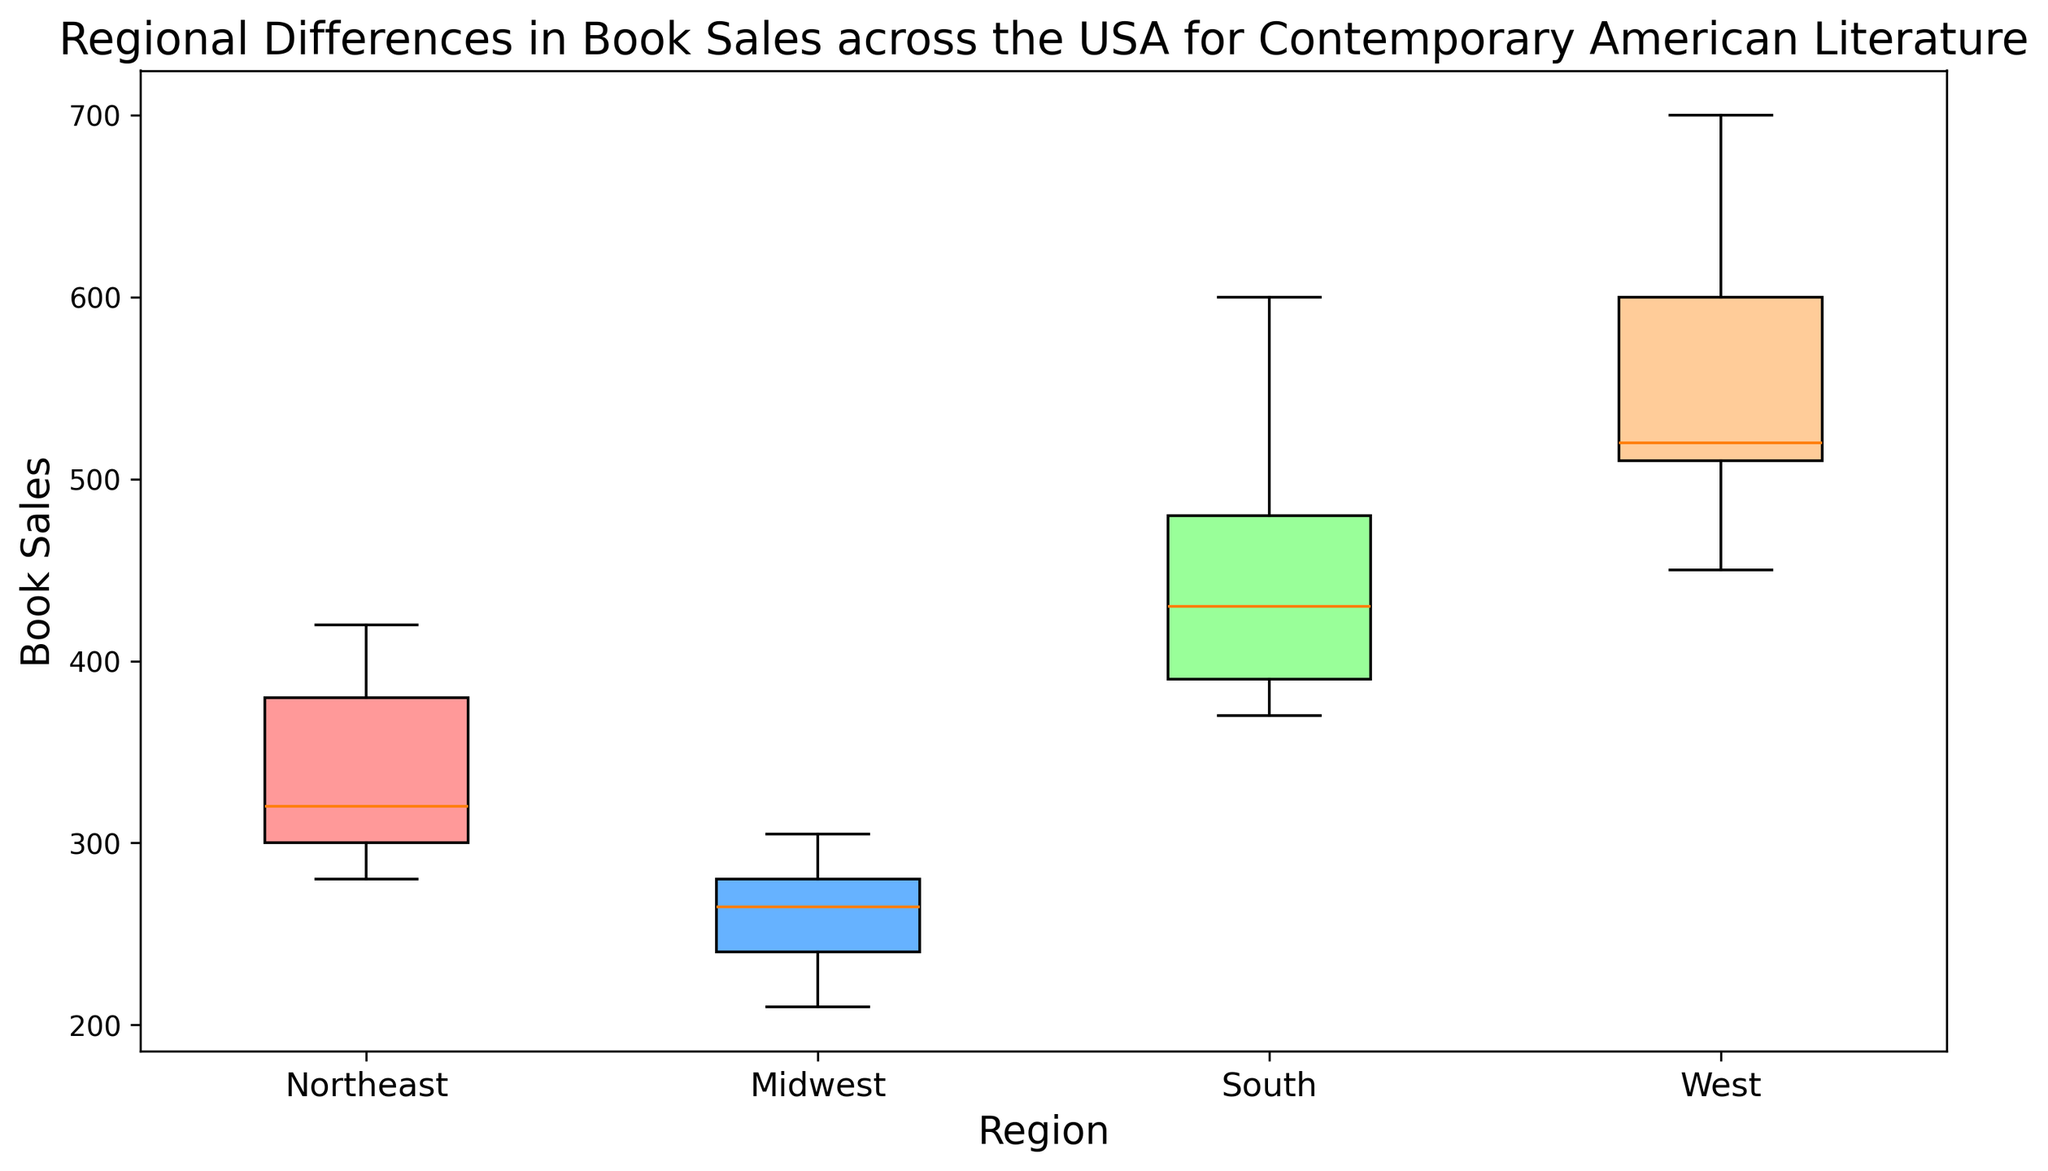Which region has the highest median book sales? To determine the region with the highest median book sales, look at the middle value of the box for each region. The West appears to have the highest central box, indicating the highest median.
Answer: West Which region shows the most variation in book sales? To determine the region with the most variation, examine the length of the boxes (interquartile range) and the whiskers (total range). The West has the longest whiskers and box, indicating a wider spread in book sales.
Answer: West Which region has the lowest minimum book sales? To identify the region with the lowest minimum, look at the bottom of the whiskers for each region. The Midwest region has the lowest whisker, indicating the lowest minimum book sales.
Answer: Midwest What is the approximate range of book sales for the Northeast region? The range is found by subtracting the minimum value from the maximum value of the whiskers for the Northeast region. The minimum is around 280, and the maximum is around 420, giving a range of 420 - 280.
Answer: 140 Which regions have book sales that exceed 500? To find which regions have book sales that exceed 500, look at the upper quantile boundary of each box plot. Both the South and West regions have upper whiskers and outliers that go beyond 500.
Answer: South, West What is the difference in the median book sales between the Midwest and Northeast regions? Find the median values (the line within each box) for both the Midwest and Northeast regions and subtract the Midwest median from the Northeast median. The Northeast median is higher and the difference is around 120.
Answer: 120 How does the interquartile range (IQR) of the South region compare to that of the Midwest region? The IQR is the length of the box. Compare the lengths of the boxes for the South and Midwest regions. The South region has a noticeably larger IQR compared to the Midwest region.
Answer: South > Midwest Which color represents the West region, and what does its color indicate? The West region color is orange (referring to "#FFCC99"), which indicates the range and variation of book sales within this region. The color itself doesn't hold specific meaning beyond visual differentiation.
Answer: Orange What can be inferred about book sales in California and Washington given their outliers in the West region? Outliers in a box plot indicate that these values are significantly different from the rest of the data. The high outliers for California and Washington suggest that these states have exceptionally high book sales compared to other Western states.
Answer: Exceptionally high Do any regions have outliers that indicate exceptionally low book sales? Outliers below the lower whisker would indicate exceptionally low book sales. Upon examining the plots, no region shows such outliers for very low sales; they all fall within the whiskers.
Answer: None 